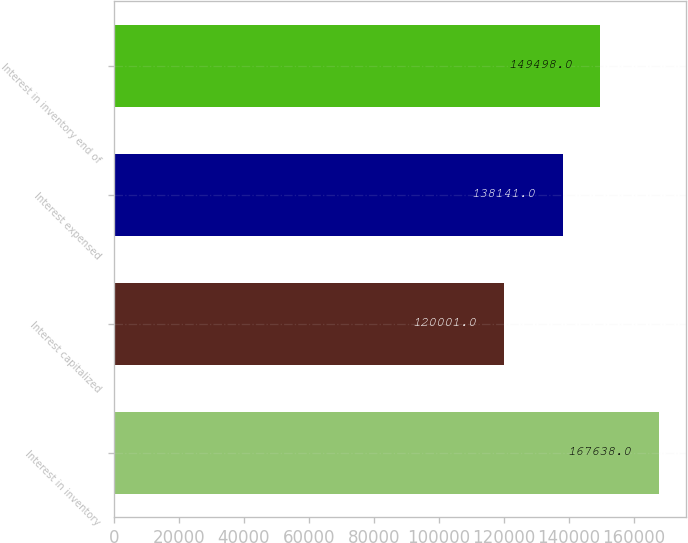Convert chart. <chart><loc_0><loc_0><loc_500><loc_500><bar_chart><fcel>Interest in inventory<fcel>Interest capitalized<fcel>Interest expensed<fcel>Interest in inventory end of<nl><fcel>167638<fcel>120001<fcel>138141<fcel>149498<nl></chart> 